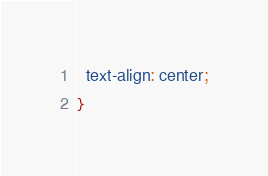Convert code to text. <code><loc_0><loc_0><loc_500><loc_500><_CSS_>  text-align: center;
}
</code> 